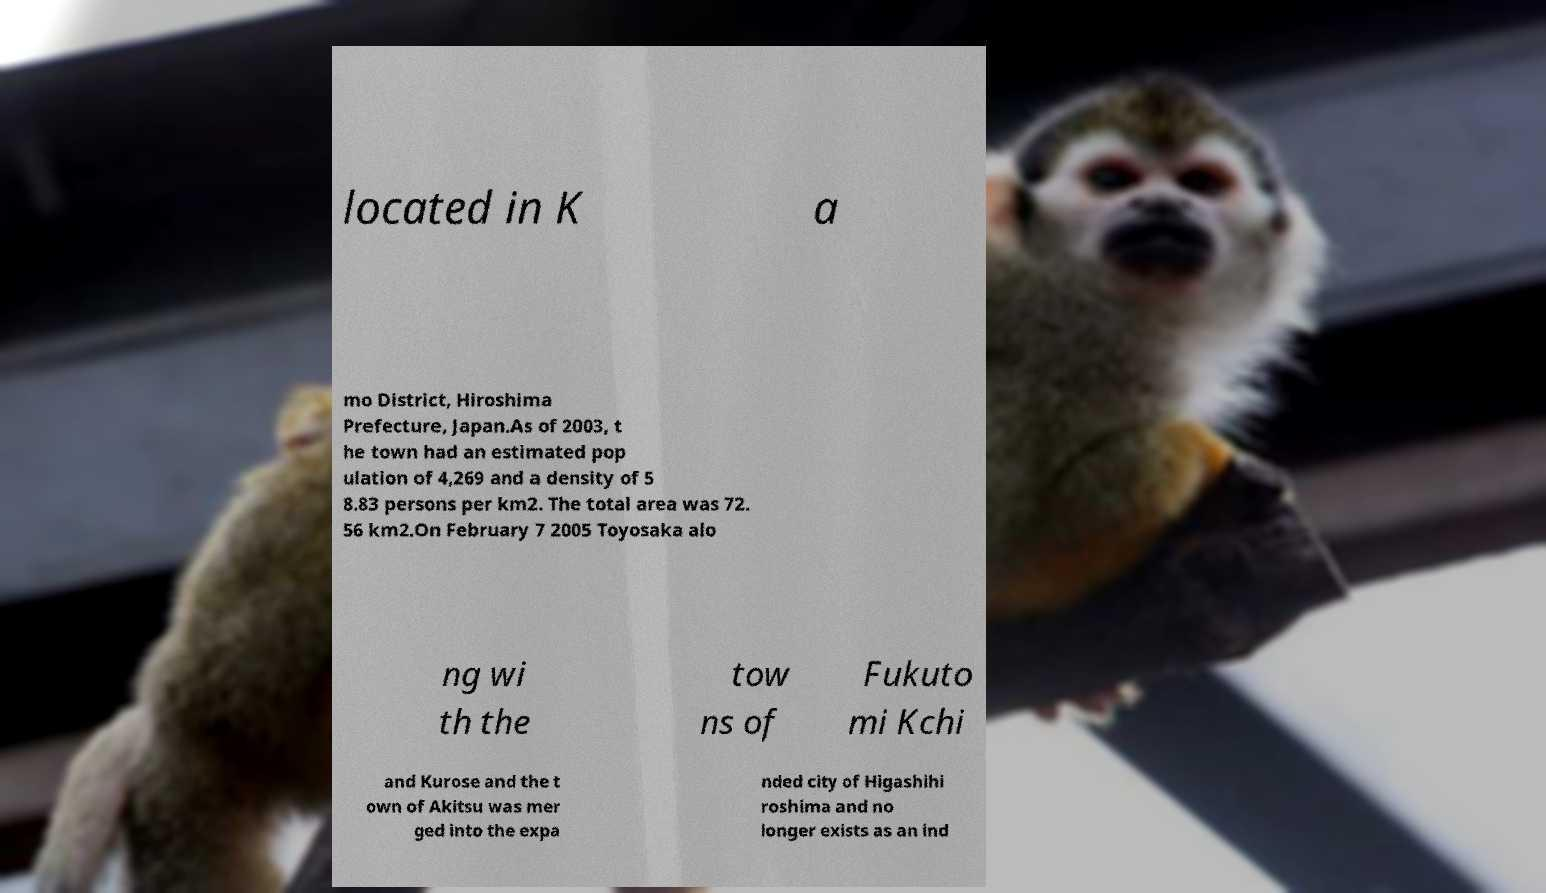What messages or text are displayed in this image? I need them in a readable, typed format. located in K a mo District, Hiroshima Prefecture, Japan.As of 2003, t he town had an estimated pop ulation of 4,269 and a density of 5 8.83 persons per km2. The total area was 72. 56 km2.On February 7 2005 Toyosaka alo ng wi th the tow ns of Fukuto mi Kchi and Kurose and the t own of Akitsu was mer ged into the expa nded city of Higashihi roshima and no longer exists as an ind 